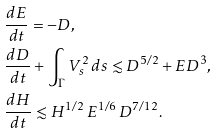<formula> <loc_0><loc_0><loc_500><loc_500>& \frac { d E } { d t } = - D , \\ & \frac { d D } { d t } + \int _ { \Gamma } V _ { s } ^ { 2 } \, d s \lesssim D ^ { 5 / 2 } + E D ^ { 3 } , \\ & \frac { d H } { d t } \lesssim H ^ { 1 / 2 } \, E ^ { 1 / 6 } \, D ^ { 7 / 1 2 } .</formula> 